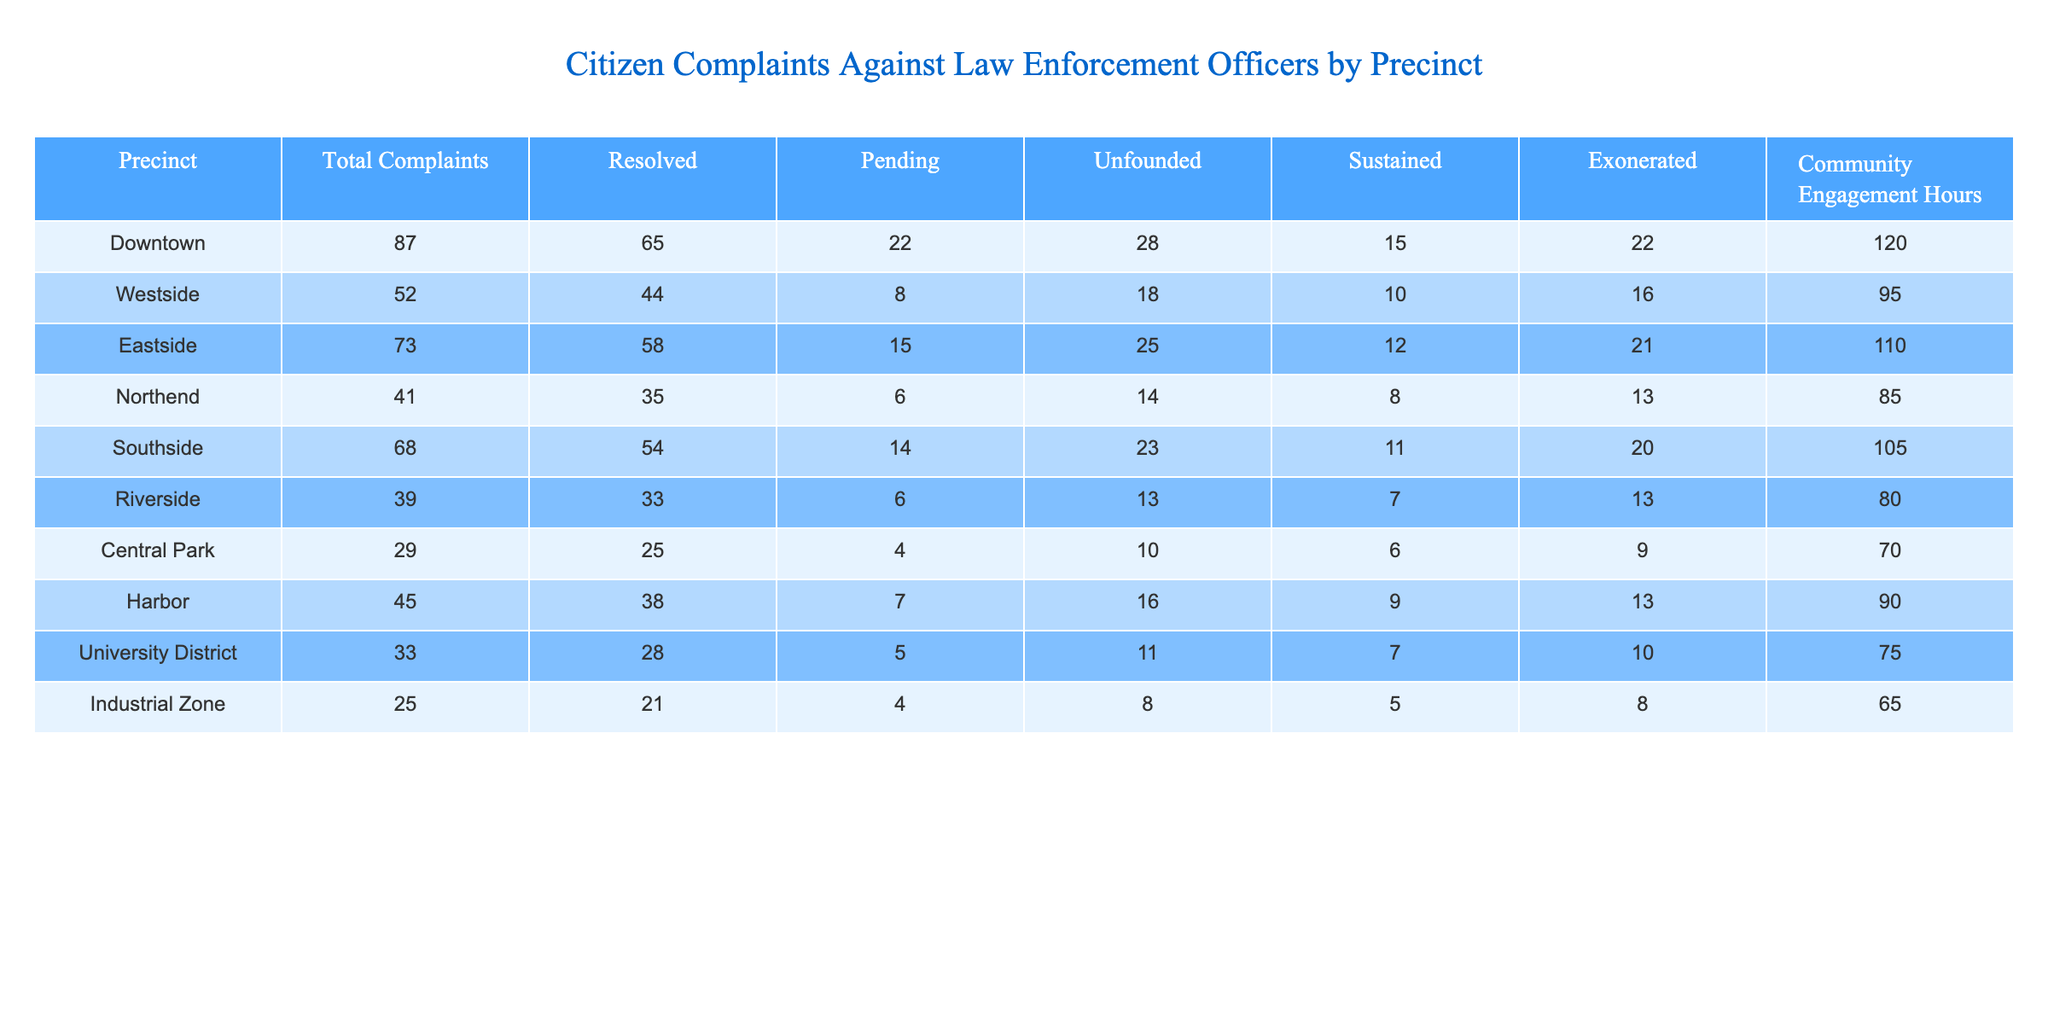What precinct has the highest number of total complaints? By examining the "Total Complaints" column, Downtown has the highest value at 87.
Answer: Downtown How many complaints are unresolved in the Eastside precinct? The "Pending" column for Eastside indicates there are 15 complaints that remain unresolved.
Answer: 15 Which precinct has the lowest number of sustained complaints? Looking at the "Sustained" column, the Industrial Zone has the lowest value with 5 sustained complaints.
Answer: Industrial Zone What is the total number of complaints across all precincts? Adding the total complaints from each precinct: 87 + 52 + 73 + 41 + 68 + 39 + 29 + 45 + 33 + 25 = 492.
Answer: 492 Is the number of resolved complaints in the University District greater than in the Riverside precinct? Riverside has 33 resolved complaints while University District has 28. Since 33 is greater than 28, the statement is true.
Answer: Yes What is the average number of community engagement hours across all precincts? Summing up the community engagement hours: 120 + 95 + 110 + 85 + 105 + 80 + 70 + 90 + 75 + 65 = 1,025. Dividing this by 10 (the number of precincts) gives an average of 102.5.
Answer: 102.5 Which precinct shows a higher resolution rate: Southside or Northend? Southside has 54 resolved out of 68 total complaints, giving a resolution rate of (54/68) = 0.794. Northend has 35 resolved out of 41 total, leading to a rate of (35/41) = 0.854. Since 0.854 > 0.794, Northend has a higher rate.
Answer: Northend How many complaints were exonerated in total across all precincts? Summing the "Exonerated" column: 22 + 16 + 21 + 13 + 20 + 13 + 9 + 13 + 10 + 8 = 165.
Answer: 165 In which precinct was the number of unfounded complaints the highest? The "Unfounded" column indicates that Downtown has the highest value of 28 unfounded complaints.
Answer: Downtown What percentage of complaints were resolved in the Westside precinct? For Westside, 44 resolved out of 52 total complaints gives a percentage of (44/52) * 100 = 84.62%.
Answer: 84.62% 